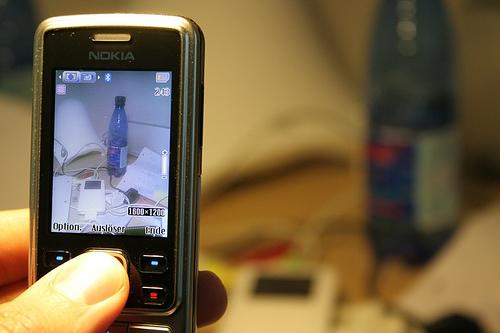What is the blue item with the black cap in the phone's image?
Short answer required. Bottle. Which thumb is on the button?
Answer briefly. Left. How many bars are left on the battery indicator?
Keep it brief. 1. 